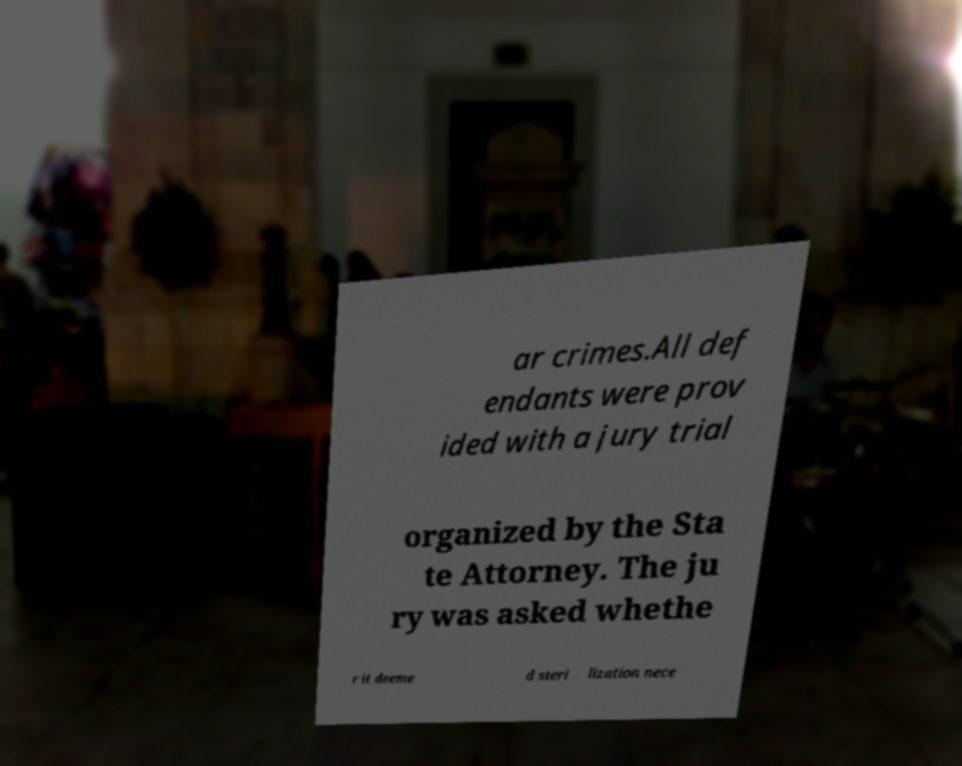For documentation purposes, I need the text within this image transcribed. Could you provide that? ar crimes.All def endants were prov ided with a jury trial organized by the Sta te Attorney. The ju ry was asked whethe r it deeme d steri lization nece 